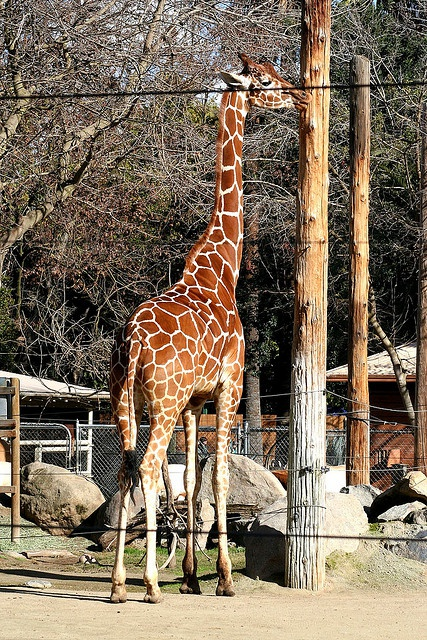Describe the objects in this image and their specific colors. I can see a giraffe in gray, ivory, black, brown, and maroon tones in this image. 